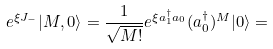Convert formula to latex. <formula><loc_0><loc_0><loc_500><loc_500>e ^ { \xi J _ { - } } | M , 0 \rangle = { \frac { 1 } { \sqrt { M ! } } } e ^ { \xi a _ { 1 } ^ { \dagger } a _ { 0 } } ( a _ { 0 } ^ { \dagger } ) ^ { M } | 0 \rangle =</formula> 